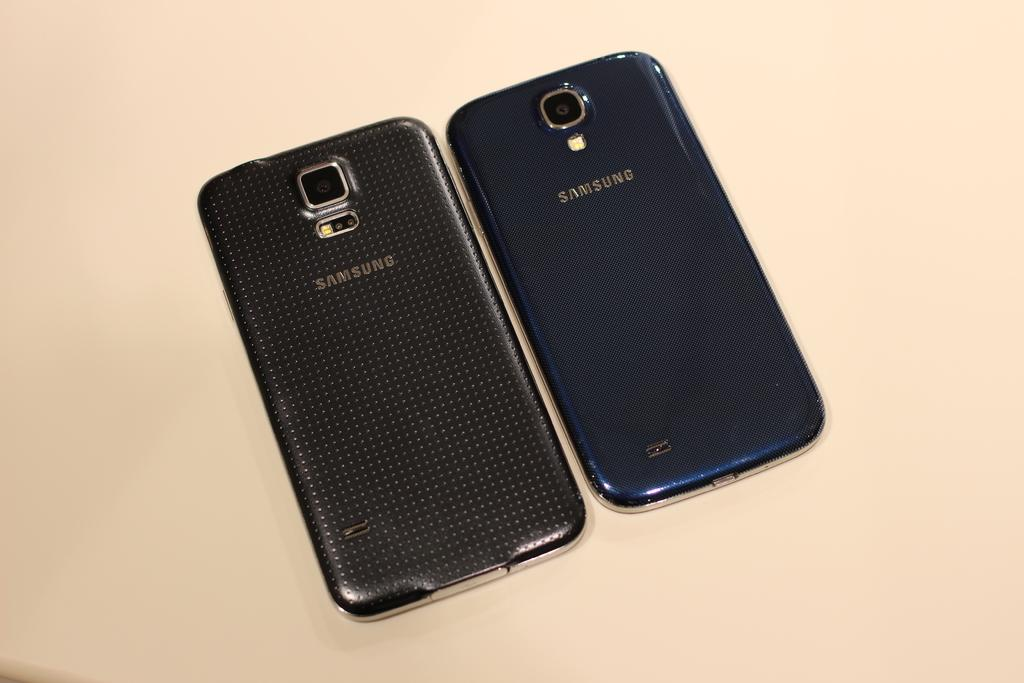<image>
Write a terse but informative summary of the picture. Two samsung phones sit side by side on a cream background. 